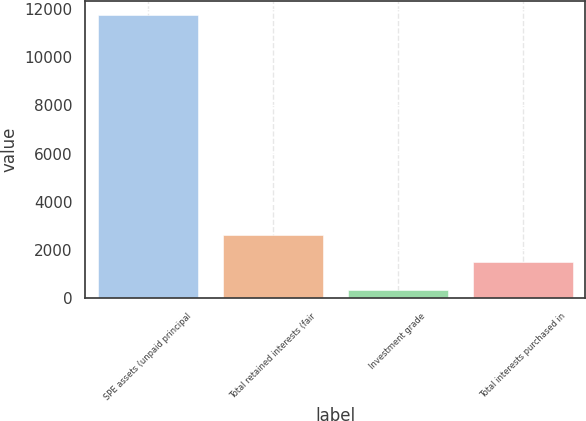Convert chart to OTSL. <chart><loc_0><loc_0><loc_500><loc_500><bar_chart><fcel>SPE assets (unpaid principal<fcel>Total retained interests (fair<fcel>Investment grade<fcel>Total interests purchased in<nl><fcel>11736<fcel>2627.2<fcel>350<fcel>1488.6<nl></chart> 